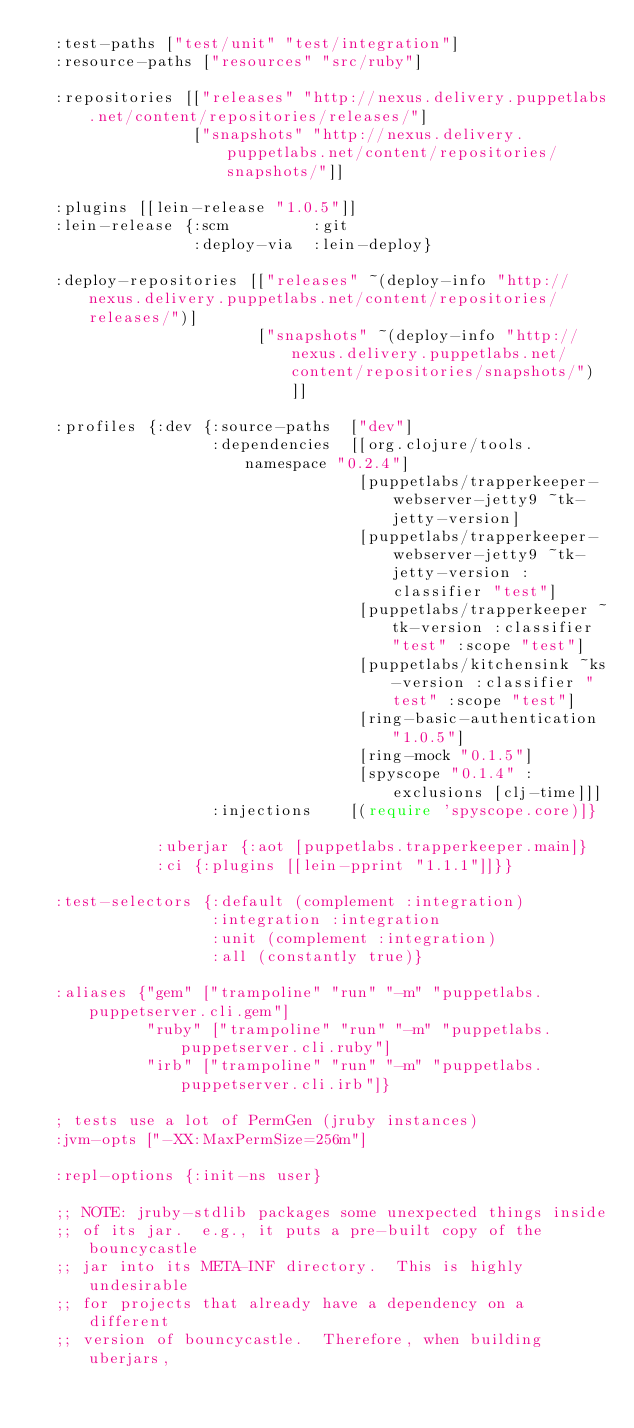<code> <loc_0><loc_0><loc_500><loc_500><_Clojure_>  :test-paths ["test/unit" "test/integration"]
  :resource-paths ["resources" "src/ruby"]

  :repositories [["releases" "http://nexus.delivery.puppetlabs.net/content/repositories/releases/"]
                 ["snapshots" "http://nexus.delivery.puppetlabs.net/content/repositories/snapshots/"]]

  :plugins [[lein-release "1.0.5"]]
  :lein-release {:scm         :git
                 :deploy-via  :lein-deploy}

  :deploy-repositories [["releases" ~(deploy-info "http://nexus.delivery.puppetlabs.net/content/repositories/releases/")]
                        ["snapshots" ~(deploy-info "http://nexus.delivery.puppetlabs.net/content/repositories/snapshots/")]]

  :profiles {:dev {:source-paths  ["dev"]
                   :dependencies  [[org.clojure/tools.namespace "0.2.4"]
                                   [puppetlabs/trapperkeeper-webserver-jetty9 ~tk-jetty-version]
                                   [puppetlabs/trapperkeeper-webserver-jetty9 ~tk-jetty-version :classifier "test"]
                                   [puppetlabs/trapperkeeper ~tk-version :classifier "test" :scope "test"]
                                   [puppetlabs/kitchensink ~ks-version :classifier "test" :scope "test"]
                                   [ring-basic-authentication "1.0.5"]
                                   [ring-mock "0.1.5"]
                                   [spyscope "0.1.4" :exclusions [clj-time]]]
                   :injections    [(require 'spyscope.core)]}

             :uberjar {:aot [puppetlabs.trapperkeeper.main]}
             :ci {:plugins [[lein-pprint "1.1.1"]]}}

  :test-selectors {:default (complement :integration)
                   :integration :integration
                   :unit (complement :integration)
                   :all (constantly true)}

  :aliases {"gem" ["trampoline" "run" "-m" "puppetlabs.puppetserver.cli.gem"]
            "ruby" ["trampoline" "run" "-m" "puppetlabs.puppetserver.cli.ruby"]
            "irb" ["trampoline" "run" "-m" "puppetlabs.puppetserver.cli.irb"]}

  ; tests use a lot of PermGen (jruby instances)
  :jvm-opts ["-XX:MaxPermSize=256m"]

  :repl-options {:init-ns user}

  ;; NOTE: jruby-stdlib packages some unexpected things inside
  ;; of its jar.  e.g., it puts a pre-built copy of the bouncycastle
  ;; jar into its META-INF directory.  This is highly undesirable
  ;; for projects that already have a dependency on a different
  ;; version of bouncycastle.  Therefore, when building uberjars,</code> 